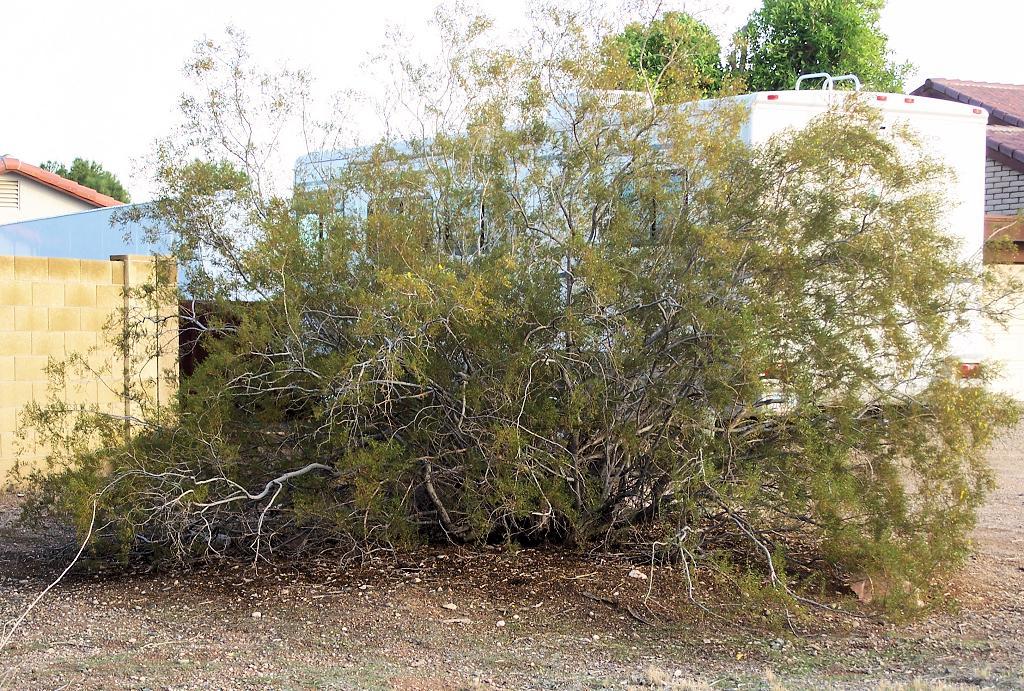How would you summarize this image in a sentence or two? In this image we can see trees, beside that we can see the wall, behind that we can see the houses, at the top we can see the sky. 